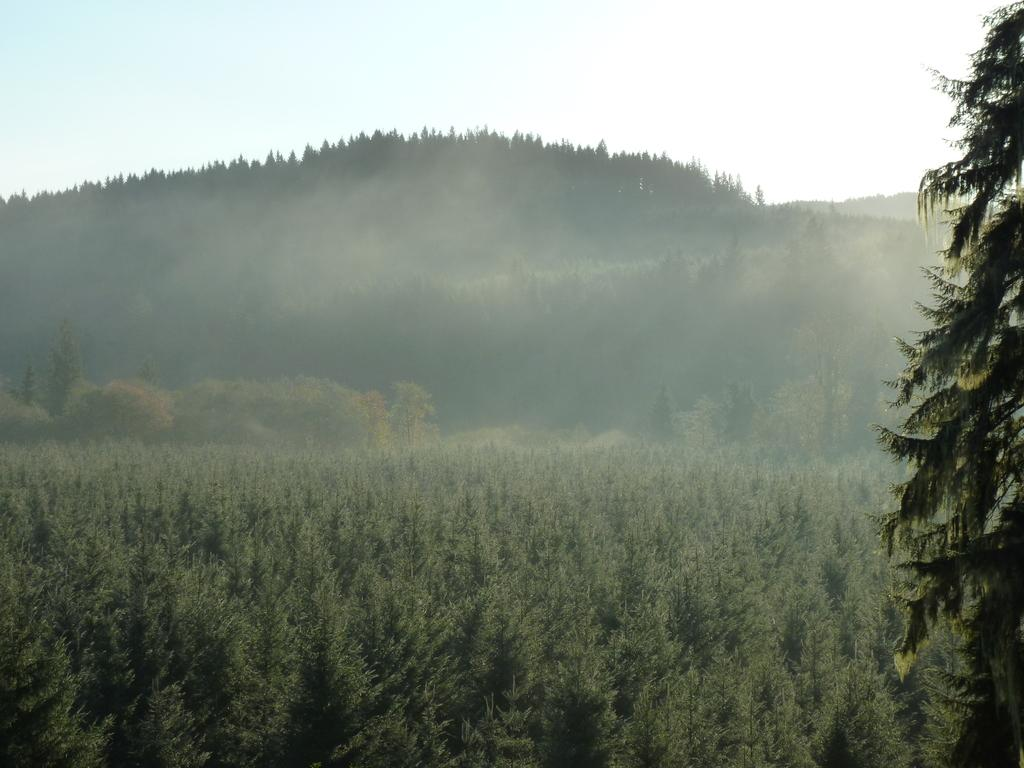What type of vegetation is present on the land in the image? There are many plants on the land in the image. Can you describe the tree located on the right side of the image? There is a tree on the right side of the image. What can be seen in the background of the image? There is a hill in the background of the image. How are the trees distributed on the hill? The hill is covered with trees. What is visible above the hill in the image? The sky is visible above the hill. How does the flock of birds fly over the hill in the image? There are no birds or flocks visible in the image; it only features plants, a tree, a hill, and the sky. 